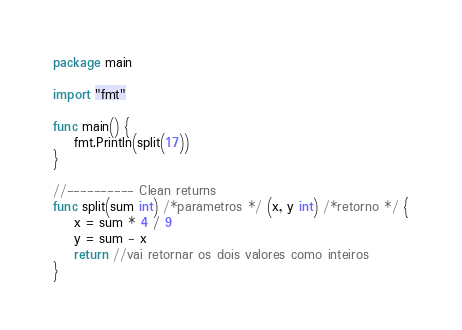Convert code to text. <code><loc_0><loc_0><loc_500><loc_500><_Go_>package main

import "fmt"

func main() {
	fmt.Println(split(17))
}

//---------- Clean returns
func split(sum int) /*parametros */ (x, y int) /*retorno */ {
	x = sum * 4 / 9
	y = sum - x
	return //vai retornar os dois valores como inteiros
}
</code> 